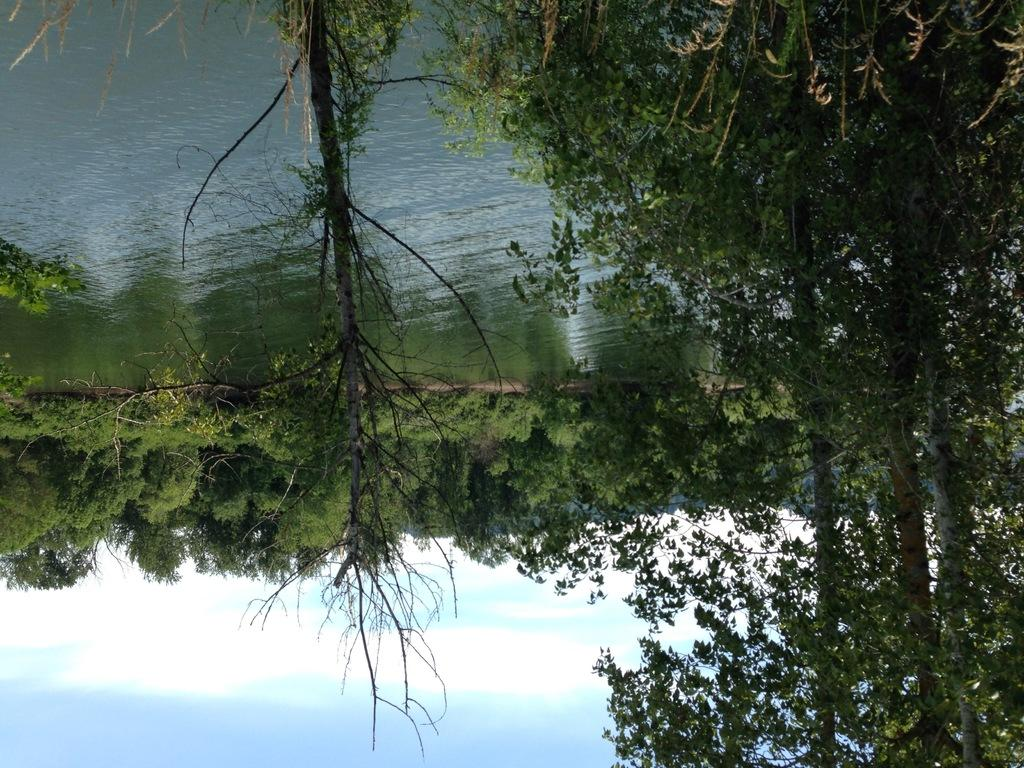What type of vegetation can be seen in the image? There are trees in the image. What natural element is visible in the image besides the trees? There is water visible in the image. What can be seen in the sky in the image? There are clouds in the image. What type of society is depicted in the image? There is no society depicted in the image; it features natural elements such as trees, water, and clouds. What is the texture of the clouds in the image? The texture of the clouds cannot be determined from the image alone, as it is a two-dimensional representation. 